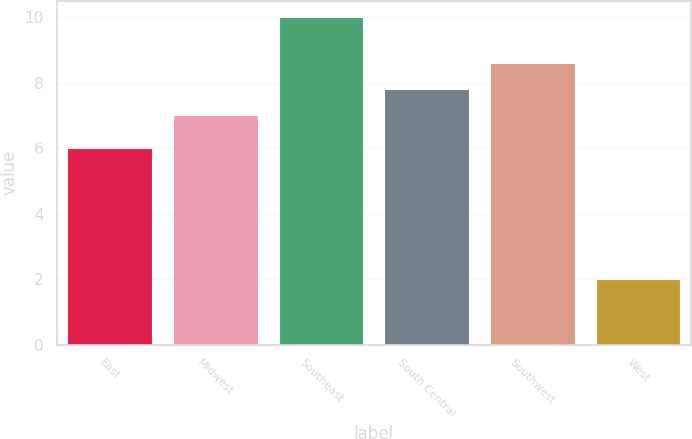<chart> <loc_0><loc_0><loc_500><loc_500><bar_chart><fcel>East<fcel>Midwest<fcel>Southeast<fcel>South Central<fcel>Southwest<fcel>West<nl><fcel>6<fcel>7<fcel>10<fcel>7.8<fcel>8.6<fcel>2<nl></chart> 